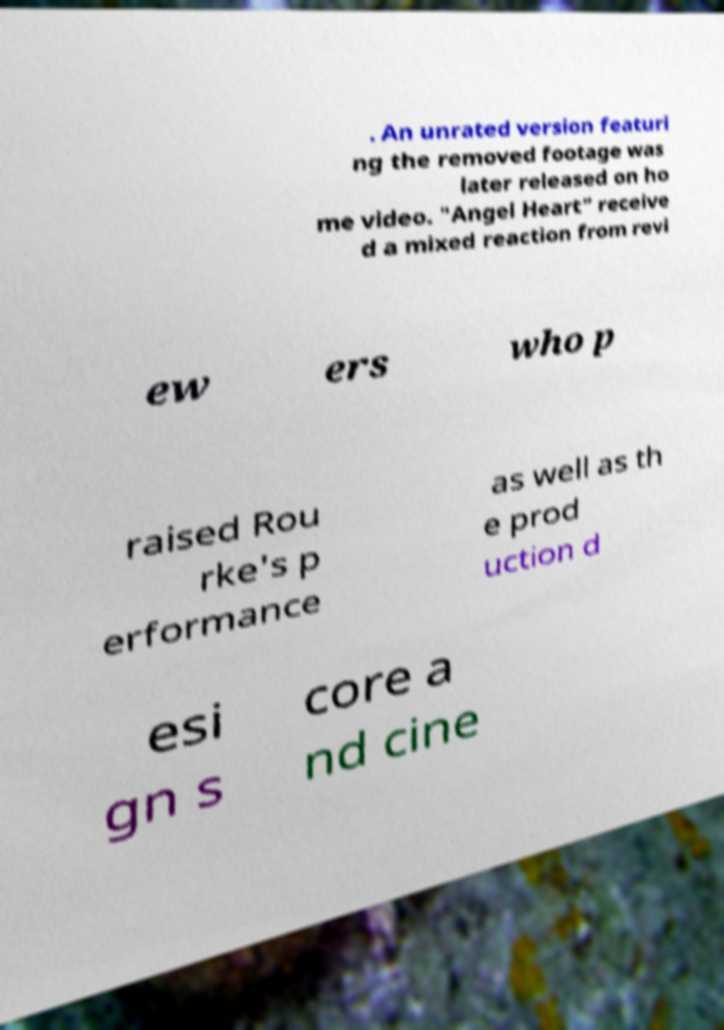Can you read and provide the text displayed in the image?This photo seems to have some interesting text. Can you extract and type it out for me? . An unrated version featuri ng the removed footage was later released on ho me video. "Angel Heart" receive d a mixed reaction from revi ew ers who p raised Rou rke's p erformance as well as th e prod uction d esi gn s core a nd cine 